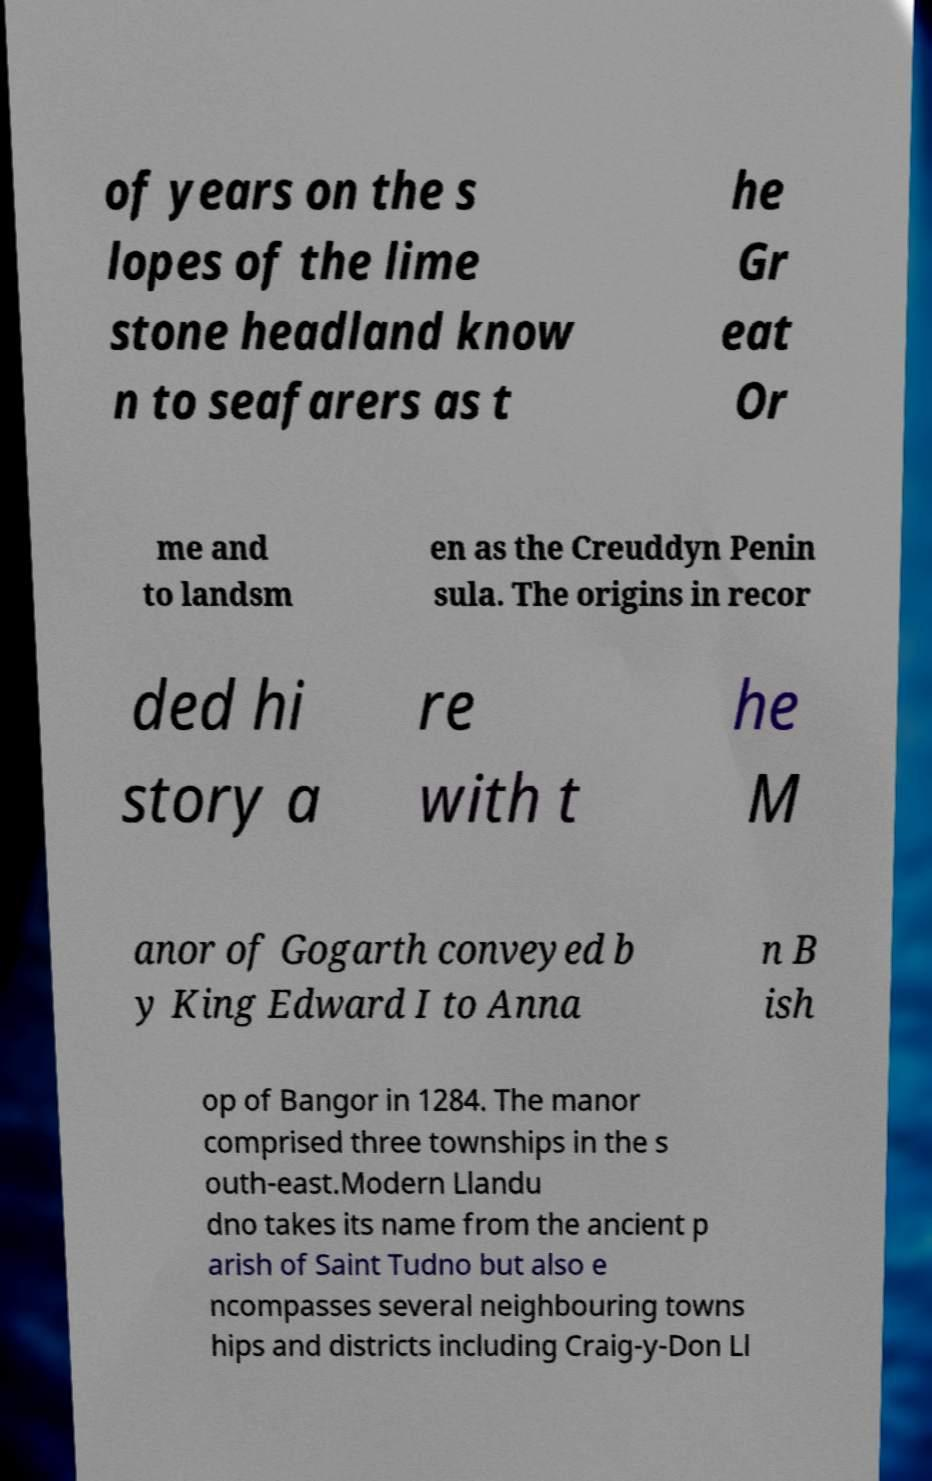Can you read and provide the text displayed in the image?This photo seems to have some interesting text. Can you extract and type it out for me? of years on the s lopes of the lime stone headland know n to seafarers as t he Gr eat Or me and to landsm en as the Creuddyn Penin sula. The origins in recor ded hi story a re with t he M anor of Gogarth conveyed b y King Edward I to Anna n B ish op of Bangor in 1284. The manor comprised three townships in the s outh-east.Modern Llandu dno takes its name from the ancient p arish of Saint Tudno but also e ncompasses several neighbouring towns hips and districts including Craig-y-Don Ll 